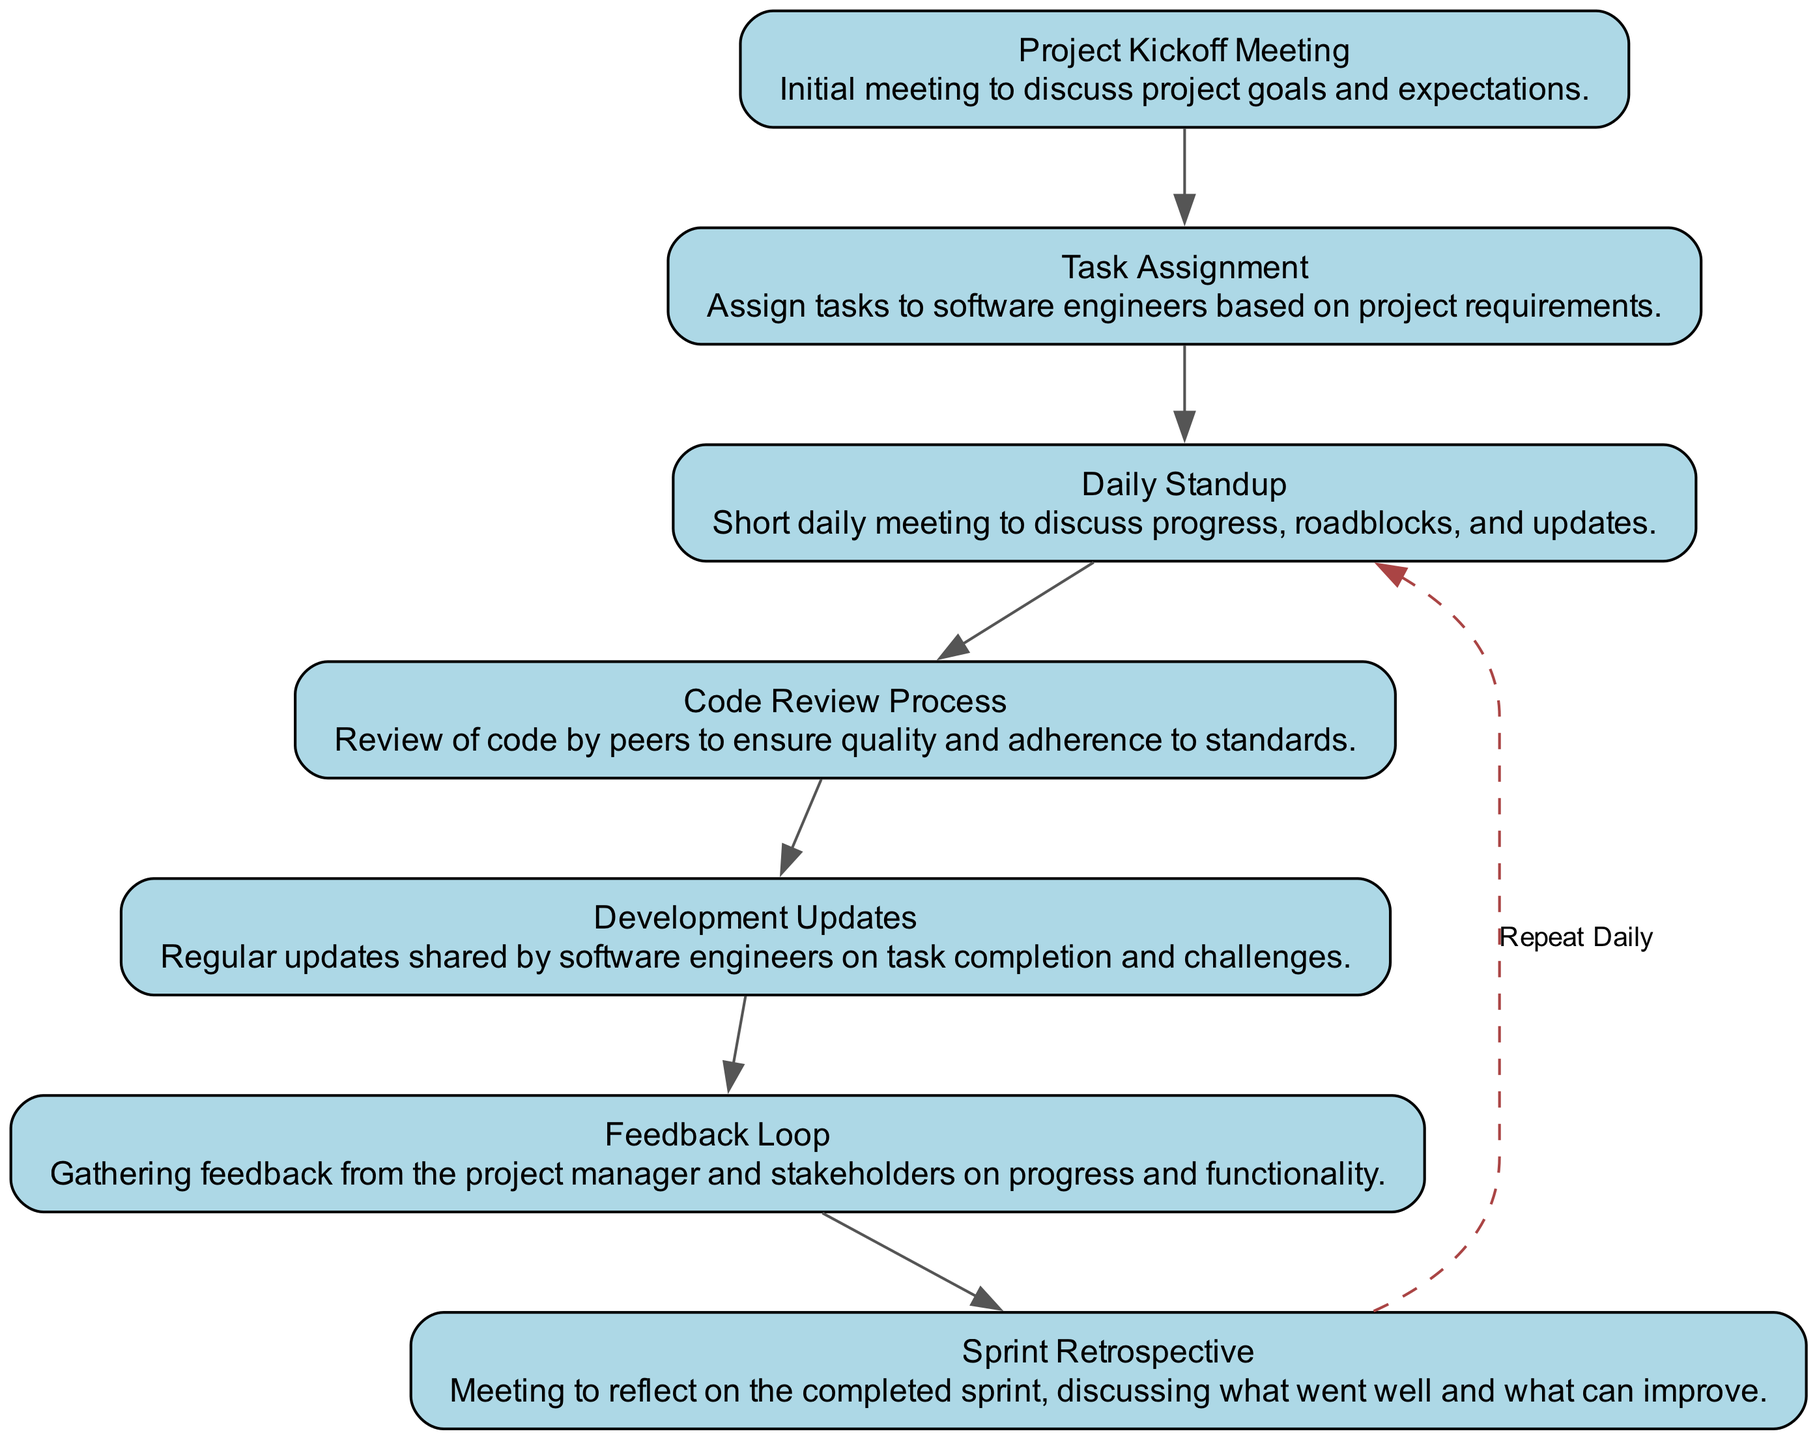What is the first step in the team communication flow? The first step in the flow is the "Project Kickoff Meeting," which is indicated as the start of the diagram.
Answer: Project Kickoff Meeting How many total nodes are present in the diagram? By counting the distinct elements provided in the diagram, there are a total of seven nodes listed, which represent different stages in the communication flow.
Answer: 7 What process occurs after "Task Assignment"? "Daily Standup" follows "Task Assignment," as shown by the connection in the flow chart, illustrating the sequence of activities.
Answer: Daily Standup Which task is repeated daily according to the diagram? The "Daily Standup" is the task that is indicated to repeat daily, as noted by the dashed looping edge that connects back to it from "Sprint Retrospective."
Answer: Daily Standup What is the main purpose of the "Sprint Retrospective"? The "Sprint Retrospective" is designed to reflect on the completed sprint to discuss what went well and what can improve, as stated in its description.
Answer: Reflect on the completed sprint What is the last node in the communication flow? The last node in the flow is "Sprint Retrospective," as it is the endpoint of the sequential processes illustrated in the diagram.
Answer: Sprint Retrospective What is required before the "Code Review Process"? The "Development Updates" must occur before the "Code Review Process," as the latter depends on the updates from software engineers regarding their task completion.
Answer: Development Updates What connects "Code Review Process" and "Feedback Loop"? A direct edge connects "Code Review Process" to "Feedback Loop," indicating that feedback occurs after the code review has taken place.
Answer: Feedback Loop How does feedback influence the communication flow? Feedback is gathered in the "Feedback Loop," which plays a crucial role in assessing progress and functionality, impacting subsequent tasks in the workflow.
Answer: Gather feedback 